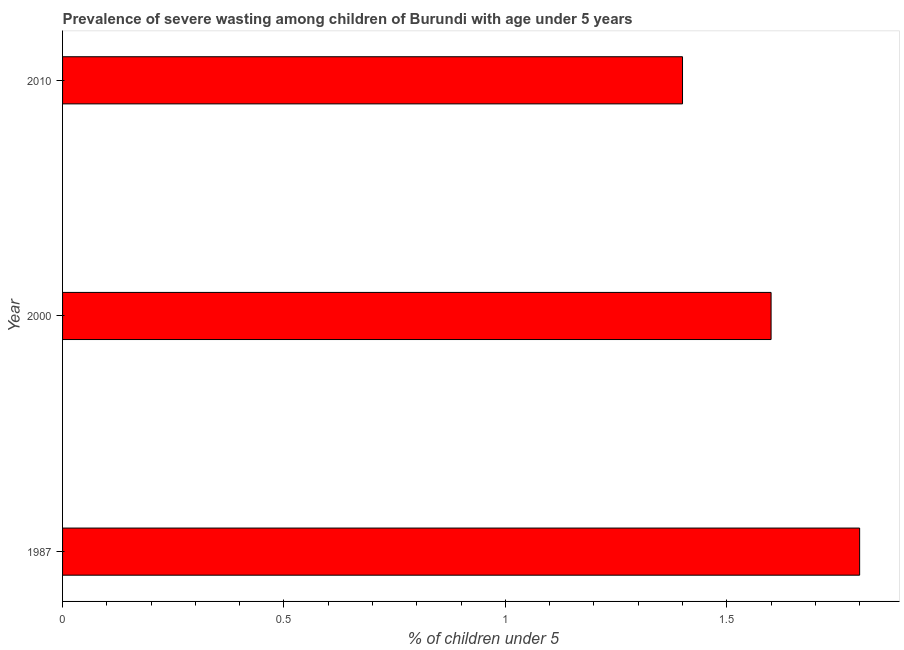Does the graph contain any zero values?
Make the answer very short. No. What is the title of the graph?
Your answer should be very brief. Prevalence of severe wasting among children of Burundi with age under 5 years. What is the label or title of the X-axis?
Keep it short and to the point.  % of children under 5. What is the prevalence of severe wasting in 2010?
Provide a short and direct response. 1.4. Across all years, what is the maximum prevalence of severe wasting?
Provide a succinct answer. 1.8. Across all years, what is the minimum prevalence of severe wasting?
Give a very brief answer. 1.4. In which year was the prevalence of severe wasting maximum?
Give a very brief answer. 1987. In which year was the prevalence of severe wasting minimum?
Your response must be concise. 2010. What is the sum of the prevalence of severe wasting?
Keep it short and to the point. 4.8. What is the difference between the prevalence of severe wasting in 1987 and 2010?
Your answer should be very brief. 0.4. What is the average prevalence of severe wasting per year?
Provide a short and direct response. 1.6. What is the median prevalence of severe wasting?
Ensure brevity in your answer.  1.6. What is the ratio of the prevalence of severe wasting in 2000 to that in 2010?
Provide a short and direct response. 1.14. Is the difference between the prevalence of severe wasting in 1987 and 2000 greater than the difference between any two years?
Your response must be concise. No. What is the difference between the highest and the lowest prevalence of severe wasting?
Your answer should be compact. 0.4. How many bars are there?
Your response must be concise. 3. What is the difference between two consecutive major ticks on the X-axis?
Provide a short and direct response. 0.5. What is the  % of children under 5 of 1987?
Offer a terse response. 1.8. What is the  % of children under 5 of 2000?
Offer a very short reply. 1.6. What is the  % of children under 5 of 2010?
Your answer should be very brief. 1.4. What is the difference between the  % of children under 5 in 1987 and 2000?
Ensure brevity in your answer.  0.2. What is the difference between the  % of children under 5 in 1987 and 2010?
Offer a terse response. 0.4. What is the ratio of the  % of children under 5 in 1987 to that in 2000?
Provide a short and direct response. 1.12. What is the ratio of the  % of children under 5 in 1987 to that in 2010?
Your answer should be compact. 1.29. What is the ratio of the  % of children under 5 in 2000 to that in 2010?
Provide a short and direct response. 1.14. 